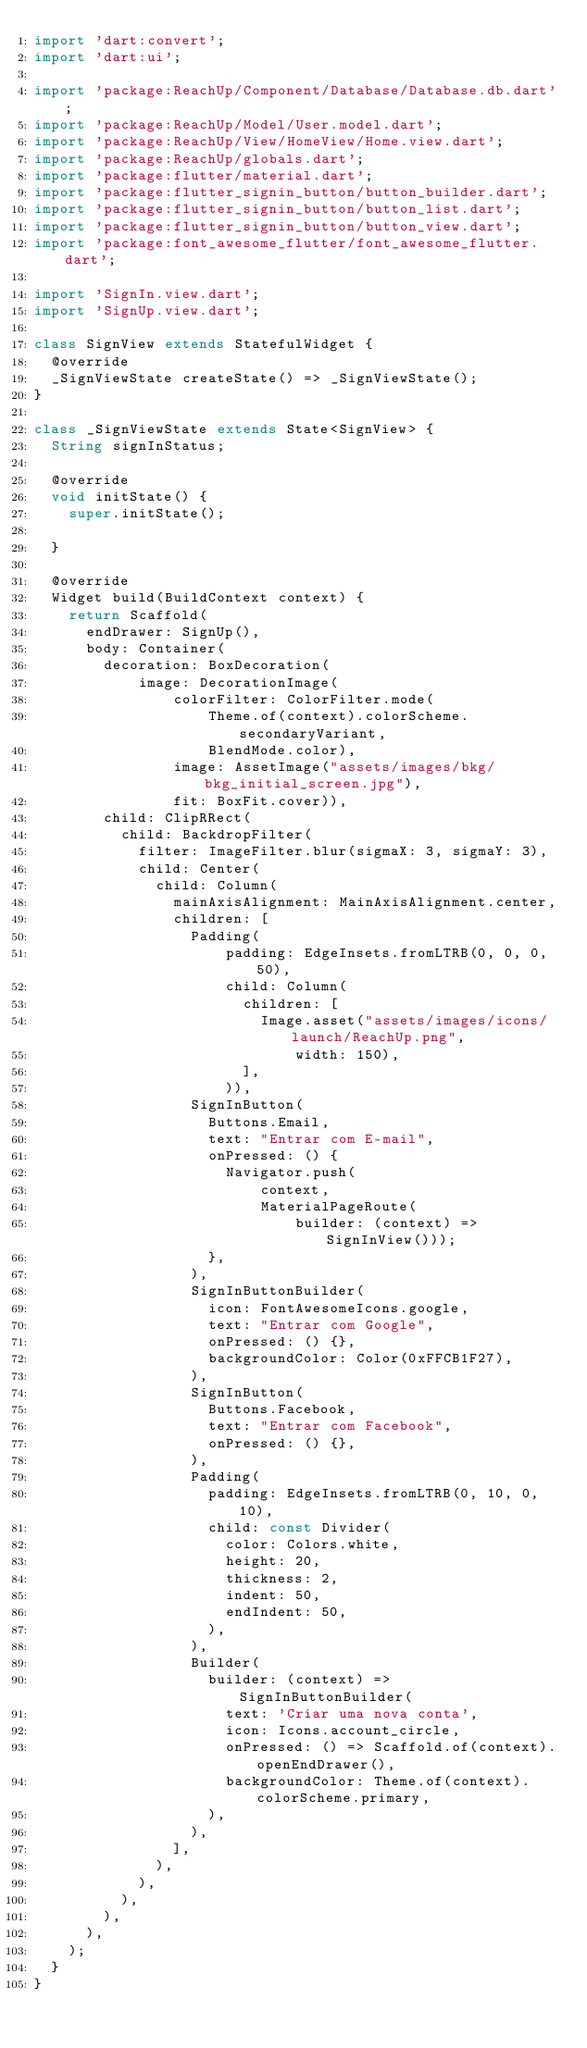<code> <loc_0><loc_0><loc_500><loc_500><_Dart_>import 'dart:convert';
import 'dart:ui';

import 'package:ReachUp/Component/Database/Database.db.dart';
import 'package:ReachUp/Model/User.model.dart';
import 'package:ReachUp/View/HomeView/Home.view.dart';
import 'package:ReachUp/globals.dart';
import 'package:flutter/material.dart';
import 'package:flutter_signin_button/button_builder.dart';
import 'package:flutter_signin_button/button_list.dart';
import 'package:flutter_signin_button/button_view.dart';
import 'package:font_awesome_flutter/font_awesome_flutter.dart';

import 'SignIn.view.dart';
import 'SignUp.view.dart';

class SignView extends StatefulWidget {
  @override
  _SignViewState createState() => _SignViewState();
}

class _SignViewState extends State<SignView> {
  String signInStatus;

  @override
  void initState() {
    super.initState();
   
  }

  @override
  Widget build(BuildContext context) {
    return Scaffold(
      endDrawer: SignUp(),
      body: Container(
        decoration: BoxDecoration(
            image: DecorationImage(
                colorFilter: ColorFilter.mode(
                    Theme.of(context).colorScheme.secondaryVariant,
                    BlendMode.color),
                image: AssetImage("assets/images/bkg/bkg_initial_screen.jpg"),
                fit: BoxFit.cover)),
        child: ClipRRect(
          child: BackdropFilter(
            filter: ImageFilter.blur(sigmaX: 3, sigmaY: 3),
            child: Center(
              child: Column(
                mainAxisAlignment: MainAxisAlignment.center,
                children: [
                  Padding(
                      padding: EdgeInsets.fromLTRB(0, 0, 0, 50),
                      child: Column(
                        children: [
                          Image.asset("assets/images/icons/launch/ReachUp.png",
                              width: 150),
                        ],
                      )),
                  SignInButton(
                    Buttons.Email,
                    text: "Entrar com E-mail",
                    onPressed: () {
                      Navigator.push(
                          context,
                          MaterialPageRoute(
                              builder: (context) => SignInView()));
                    },
                  ),
                  SignInButtonBuilder(
                    icon: FontAwesomeIcons.google,
                    text: "Entrar com Google",
                    onPressed: () {},
                    backgroundColor: Color(0xFFCB1F27),
                  ),
                  SignInButton(
                    Buttons.Facebook,
                    text: "Entrar com Facebook",
                    onPressed: () {},
                  ),
                  Padding(
                    padding: EdgeInsets.fromLTRB(0, 10, 0, 10),
                    child: const Divider(
                      color: Colors.white,
                      height: 20,
                      thickness: 2,
                      indent: 50,
                      endIndent: 50,
                    ),
                  ),
                  Builder(
                    builder: (context) => SignInButtonBuilder(
                      text: 'Criar uma nova conta',
                      icon: Icons.account_circle,
                      onPressed: () => Scaffold.of(context).openEndDrawer(),
                      backgroundColor: Theme.of(context).colorScheme.primary,
                    ),
                  ),
                ],
              ),
            ),
          ),
        ),
      ),
    );
  }
}
</code> 